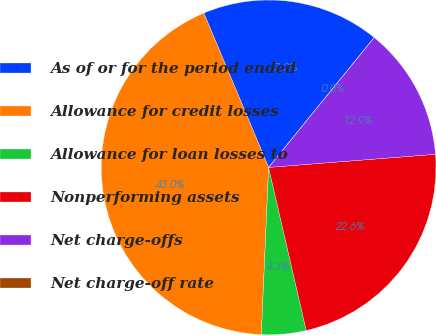Convert chart. <chart><loc_0><loc_0><loc_500><loc_500><pie_chart><fcel>As of or for the period ended<fcel>Allowance for credit losses<fcel>Allowance for loan losses to<fcel>Nonperforming assets<fcel>Net charge-offs<fcel>Net charge-off rate<nl><fcel>17.19%<fcel>42.98%<fcel>4.3%<fcel>22.64%<fcel>12.89%<fcel>0.0%<nl></chart> 